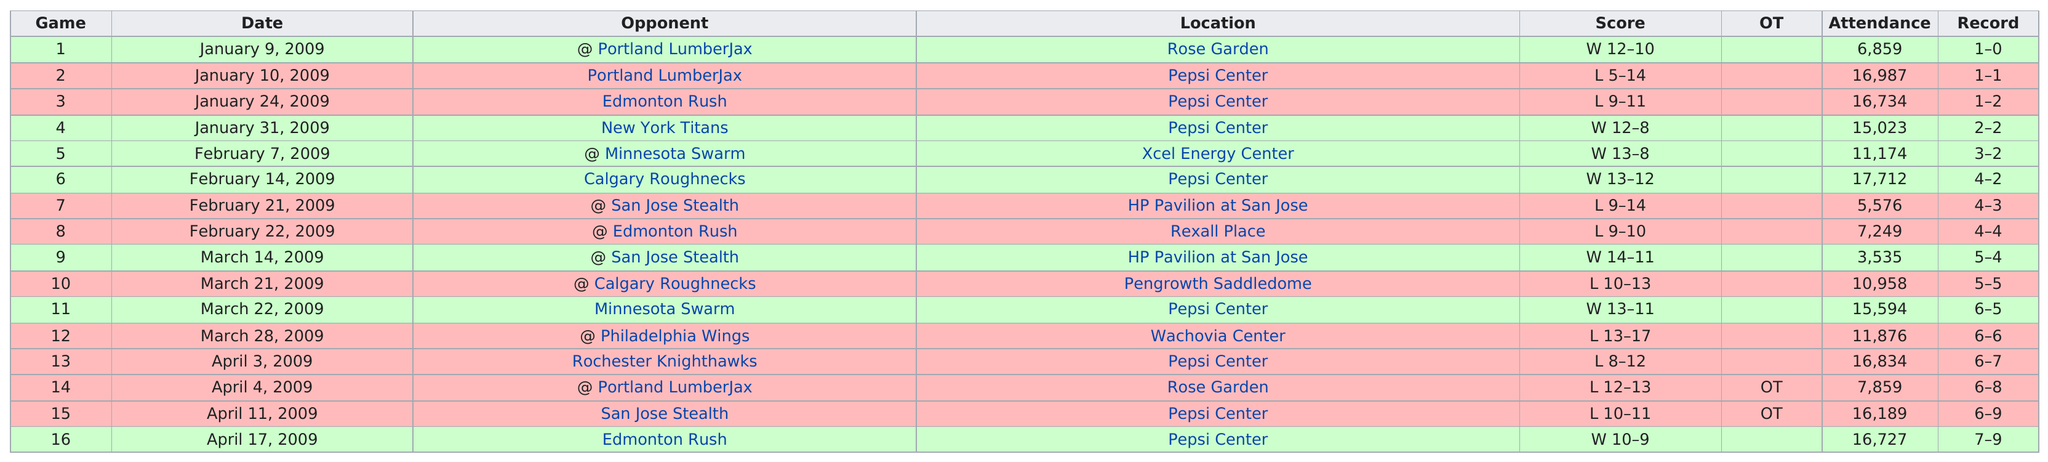List a handful of essential elements in this visual. The total attendance in January 2009 was approximately 55,603. The top attendance for this season was 17,712. In 2009, they won 7 games. On January 9, 2009, the average number in attendance for games against the Portland Lumberjax was 6,859. On April 17, 2009, the last game was played. 